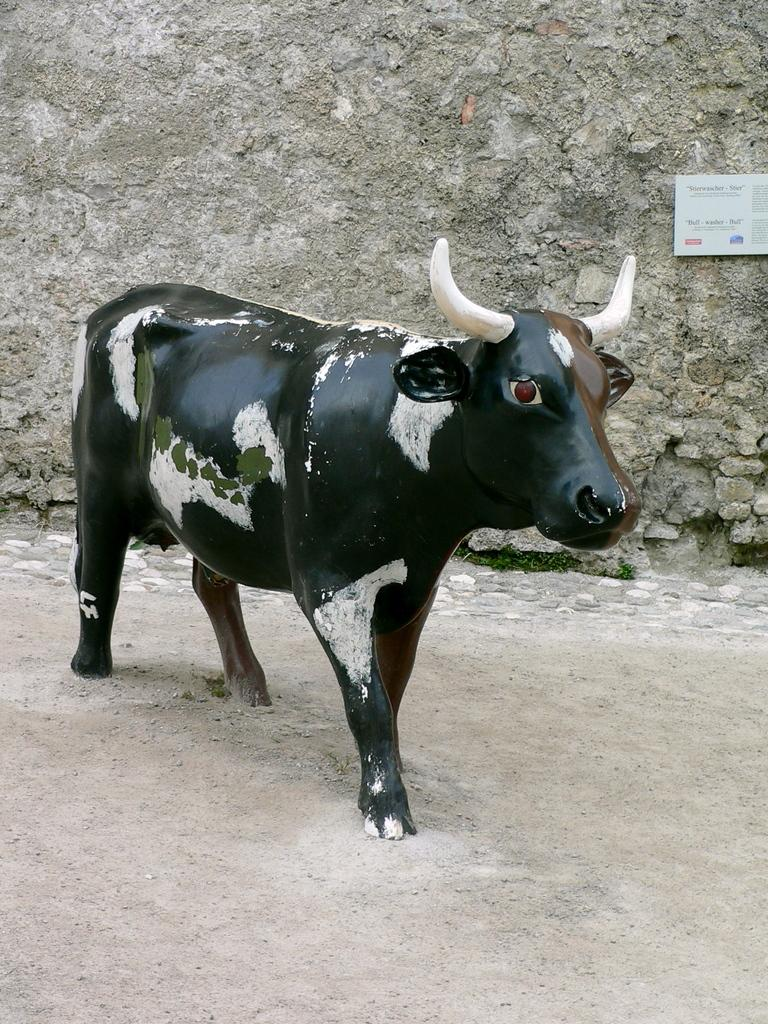What is the main subject of the image? There is a statue of a cow in the image. Can you describe the statue's surroundings? There is a wall behind the statue in the image. What type of fuel is being used by the cow in the image? There is no indication in the image that the cow is using any fuel, as it is a statue and not a living animal. 